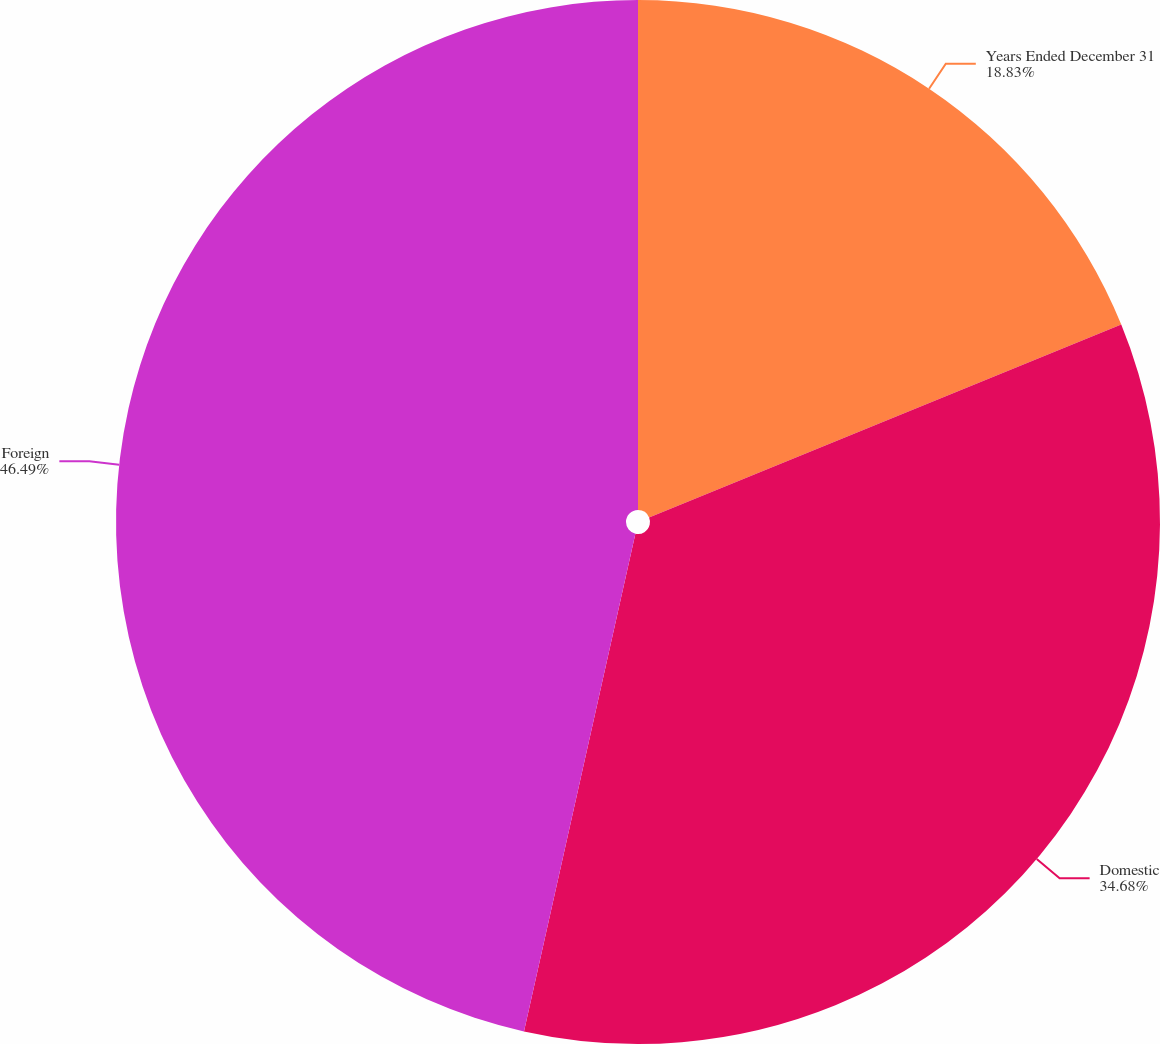<chart> <loc_0><loc_0><loc_500><loc_500><pie_chart><fcel>Years Ended December 31<fcel>Domestic<fcel>Foreign<nl><fcel>18.83%<fcel>34.68%<fcel>46.5%<nl></chart> 